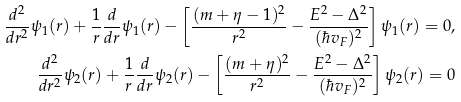<formula> <loc_0><loc_0><loc_500><loc_500>\frac { d ^ { 2 } } { d r ^ { 2 } } \psi _ { 1 } ( r ) + \frac { 1 } { r } \frac { d } { d r } \psi _ { 1 } ( r ) - \left [ \frac { ( m + \eta - 1 ) ^ { 2 } } { r ^ { 2 } } - \frac { E ^ { 2 } - \Delta ^ { 2 } } { ( \hbar { v } _ { F } ) ^ { 2 } } \right ] \psi _ { 1 } ( r ) = 0 , \\ \frac { d ^ { 2 } } { d r ^ { 2 } } \psi _ { 2 } ( r ) + \frac { 1 } { r } \frac { d } { d r } \psi _ { 2 } ( r ) - \left [ \frac { ( m + \eta ) ^ { 2 } } { r ^ { 2 } } - \frac { E ^ { 2 } - \Delta ^ { 2 } } { ( \hbar { v } _ { F } ) ^ { 2 } } \right ] \psi _ { 2 } ( r ) = 0</formula> 